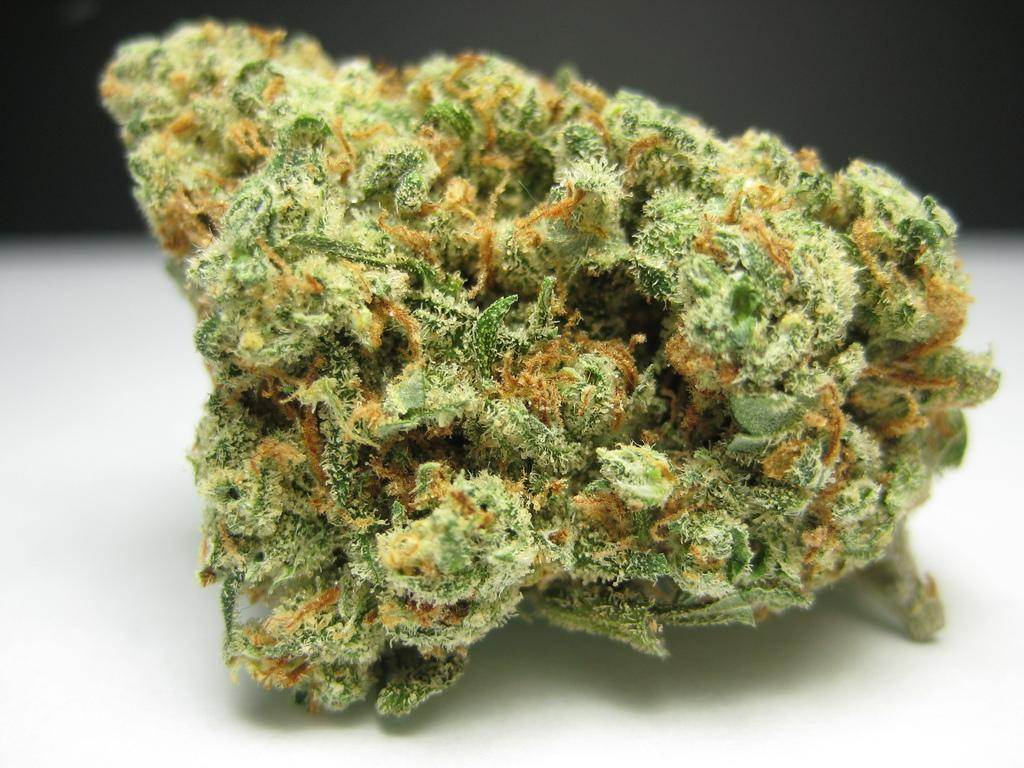What is the color of the fungus-like substance on the item in the image? The fungus-like substance on the item is green. Can you describe the item with the fungus-like substance? The item is not specified, but it has a green fungus-like substance on it. Where is the item with the fungus-like substance located? The item is on a platform. Can you see a house with a grassy lawn and an owl perched on a tree in the image? There is no mention of a house, grass, or owl in the provided facts, so these elements are not present in the image. 